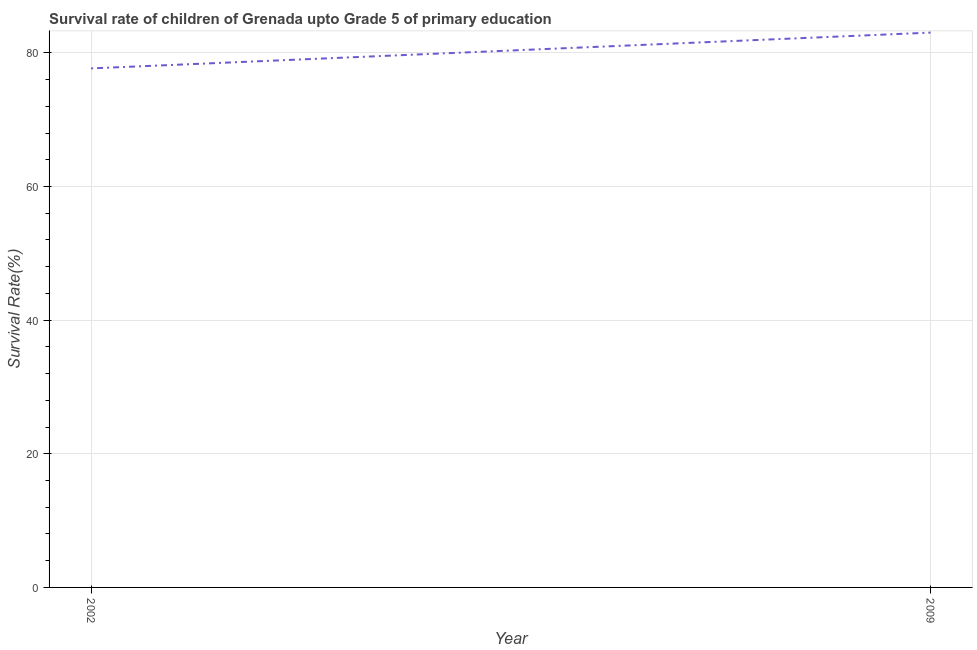What is the survival rate in 2002?
Offer a very short reply. 77.68. Across all years, what is the maximum survival rate?
Provide a short and direct response. 83.04. Across all years, what is the minimum survival rate?
Ensure brevity in your answer.  77.68. What is the sum of the survival rate?
Keep it short and to the point. 160.72. What is the difference between the survival rate in 2002 and 2009?
Provide a succinct answer. -5.36. What is the average survival rate per year?
Keep it short and to the point. 80.36. What is the median survival rate?
Provide a short and direct response. 80.36. In how many years, is the survival rate greater than 68 %?
Provide a short and direct response. 2. What is the ratio of the survival rate in 2002 to that in 2009?
Your response must be concise. 0.94. Is the survival rate in 2002 less than that in 2009?
Provide a succinct answer. Yes. In how many years, is the survival rate greater than the average survival rate taken over all years?
Keep it short and to the point. 1. Does the survival rate monotonically increase over the years?
Provide a short and direct response. Yes. How many lines are there?
Make the answer very short. 1. How many years are there in the graph?
Your answer should be compact. 2. What is the difference between two consecutive major ticks on the Y-axis?
Offer a very short reply. 20. Are the values on the major ticks of Y-axis written in scientific E-notation?
Your response must be concise. No. Does the graph contain any zero values?
Ensure brevity in your answer.  No. Does the graph contain grids?
Your response must be concise. Yes. What is the title of the graph?
Ensure brevity in your answer.  Survival rate of children of Grenada upto Grade 5 of primary education. What is the label or title of the X-axis?
Offer a terse response. Year. What is the label or title of the Y-axis?
Keep it short and to the point. Survival Rate(%). What is the Survival Rate(%) in 2002?
Keep it short and to the point. 77.68. What is the Survival Rate(%) in 2009?
Provide a succinct answer. 83.04. What is the difference between the Survival Rate(%) in 2002 and 2009?
Give a very brief answer. -5.36. What is the ratio of the Survival Rate(%) in 2002 to that in 2009?
Make the answer very short. 0.94. 